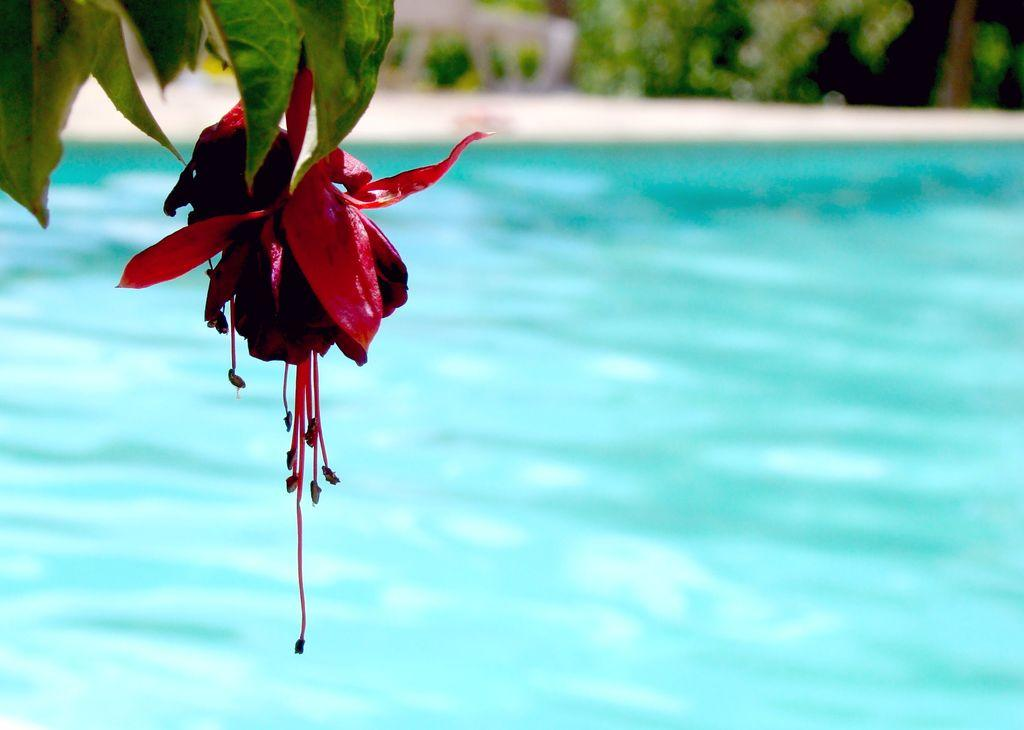What is the primary element in the image? There is water in the image. What can be seen on the left side of the image? There are leaves and a flower on the left side of the image. How many flowers are visible in the image? There is one flower visible in the image. What is the quality of the background in the image? The background of the image is blurred. What types of objects and plants can be seen in the background of the image? Objects and plants are visible in the background of the image. What type of tooth is visible in the image? There is no tooth visible in the image. How many stars are present in the image? There are no stars present in the image. 